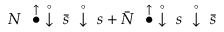Convert formula to latex. <formula><loc_0><loc_0><loc_500><loc_500>N \stackrel { \uparrow } { \bullet } \stackrel { \circ } { \downarrow } \bar { s } \stackrel { \circ } { \downarrow } s + \bar { N } \stackrel { \uparrow } { \bullet } \stackrel { \circ } { \downarrow } s \stackrel { \circ } { \downarrow } \bar { s }</formula> 